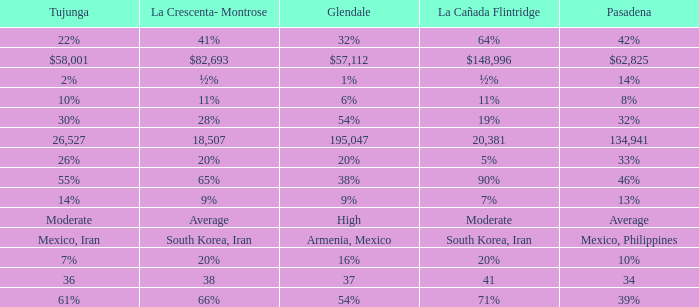What is the figure for La Canada Flintridge when Pasadena is 34? 41.0. 